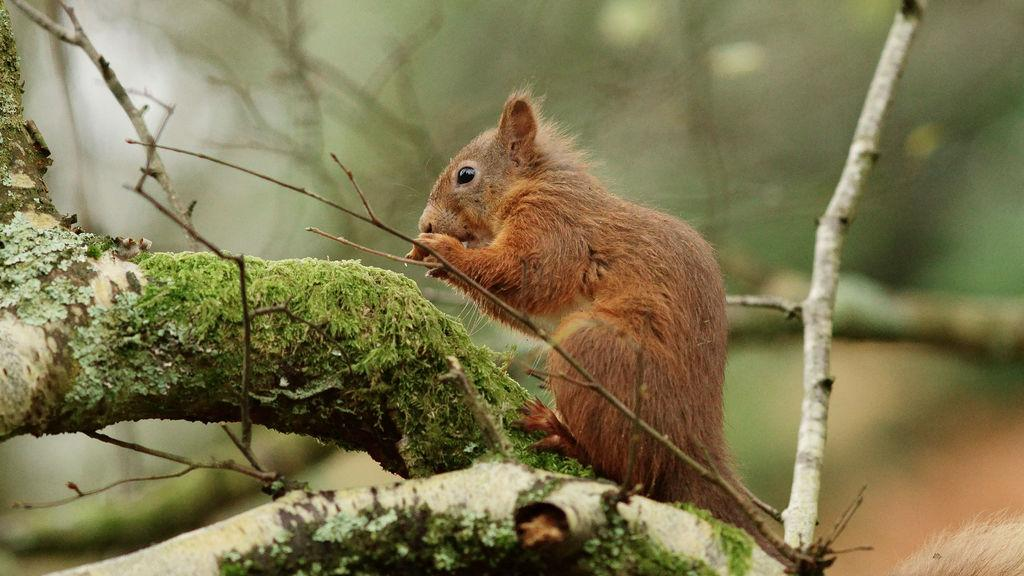What animal can be seen in the image? There is a squirrel in the image. Where is the squirrel located? The squirrel is sitting on a branch. What is the color of the squirrel? The squirrel is brown in color. What color is the background of the image? The background of the image is green. What stage of development is the pear in the image? There is no pear present in the image, so it is not possible to determine its stage of development. 